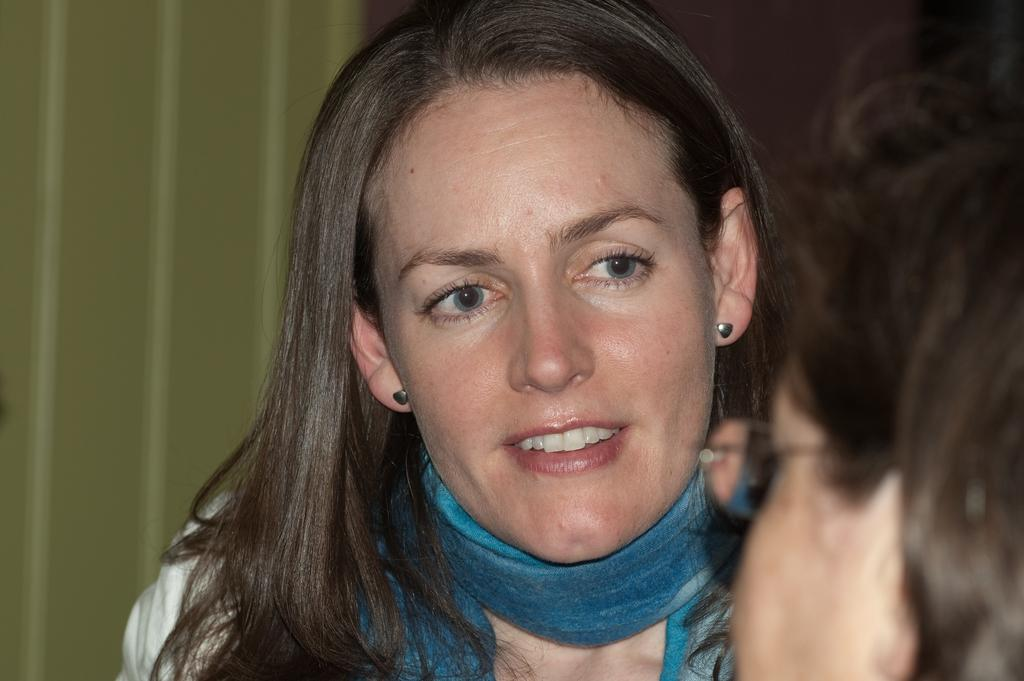How many people are in the image? There are two persons in the image. Can you describe one of the persons? One of the persons is wearing spectacles. What can be seen in the background of the image? There is a wall in the background of the image. How many lizards can be seen jumping on the wall in the image? There are no lizards or jumping activity present in the image; it features two persons and a wall in the background. 